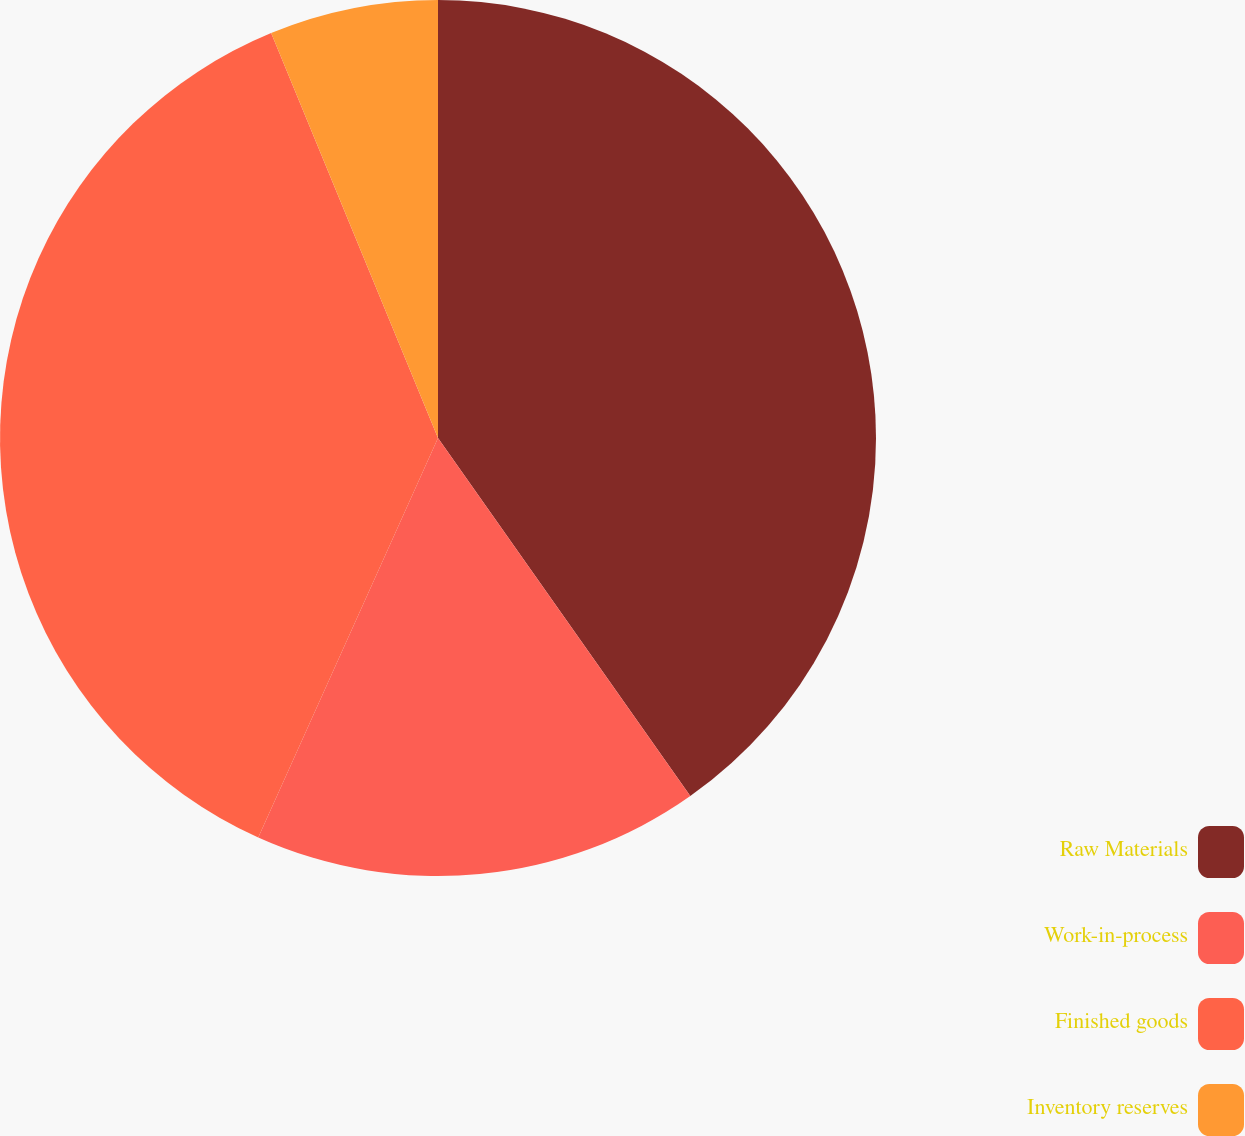<chart> <loc_0><loc_0><loc_500><loc_500><pie_chart><fcel>Raw Materials<fcel>Work-in-process<fcel>Finished goods<fcel>Inventory reserves<nl><fcel>40.23%<fcel>16.5%<fcel>37.05%<fcel>6.22%<nl></chart> 